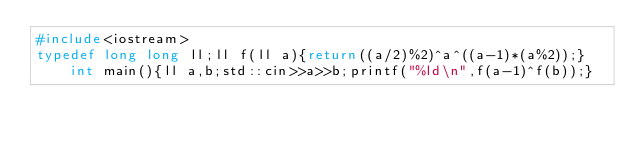<code> <loc_0><loc_0><loc_500><loc_500><_C++_>#include<iostream>
typedef long long ll;ll f(ll a){return((a/2)%2)^a^((a-1)*(a%2));}int main(){ll a,b;std::cin>>a>>b;printf("%ld\n",f(a-1)^f(b));}</code> 